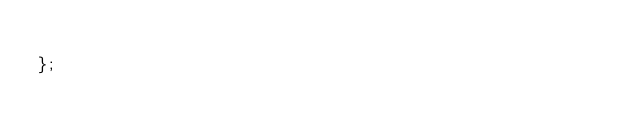<code> <loc_0><loc_0><loc_500><loc_500><_JavaScript_>	
};

</code> 